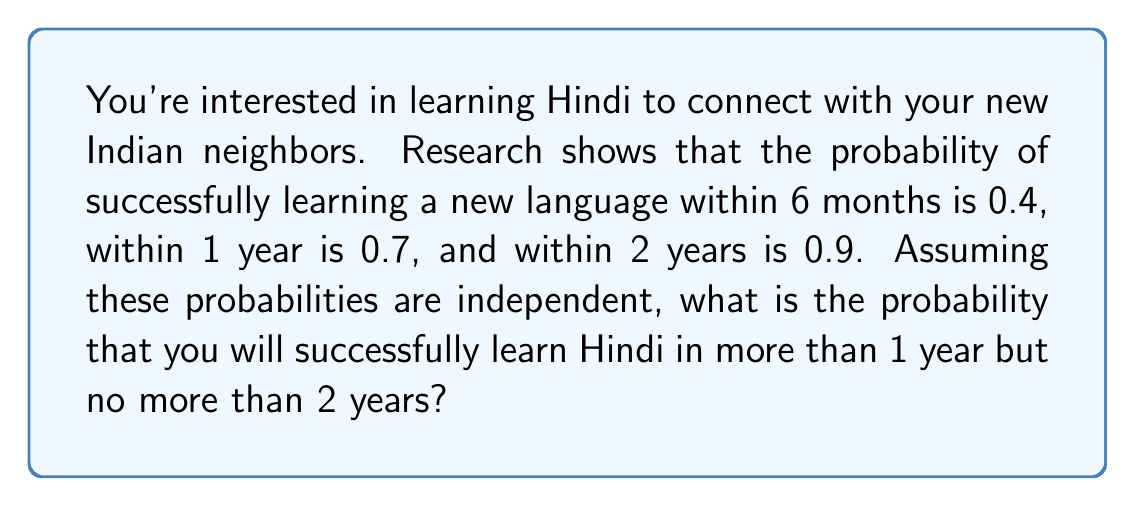Teach me how to tackle this problem. Let's approach this step-by-step:

1) First, let's define our events:
   A: Successfully learning Hindi within 6 months
   B: Successfully learning Hindi within 1 year
   C: Successfully learning Hindi within 2 years

2) We're given the following probabilities:
   $P(A) = 0.4$
   $P(B) = 0.7$
   $P(C) = 0.9$

3) We want to find the probability of learning Hindi in more than 1 year but no more than 2 years. This is equivalent to the probability of learning Hindi within 2 years minus the probability of learning Hindi within 1 year:

   $P(\text{1 year < Learning Hindi ≤ 2 years}) = P(C) - P(B)$

4) Substituting the given probabilities:

   $P(\text{1 year < Learning Hindi ≤ 2 years}) = 0.9 - 0.7 = 0.2$

Therefore, the probability of successfully learning Hindi in more than 1 year but no more than 2 years is 0.2 or 20%.
Answer: 0.2 